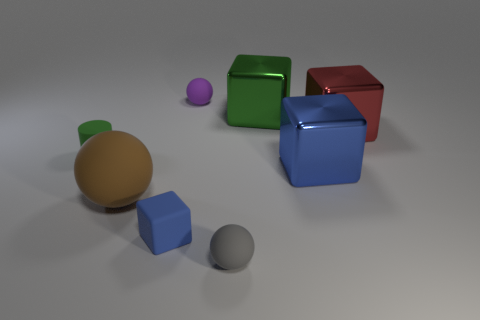Is the number of tiny gray rubber balls on the right side of the tiny gray rubber sphere the same as the number of big spheres behind the blue shiny block? After reviewing the image, it's observable that there is one tiny gray rubber ball on the right side of a larger gray sphere. Regarding the big spheres behind the blue shiny block, there appears to be only one visible large sphere, which has a greenish hue. Therefore, the counts of the specified objects are indeed the same: there is one of each. 